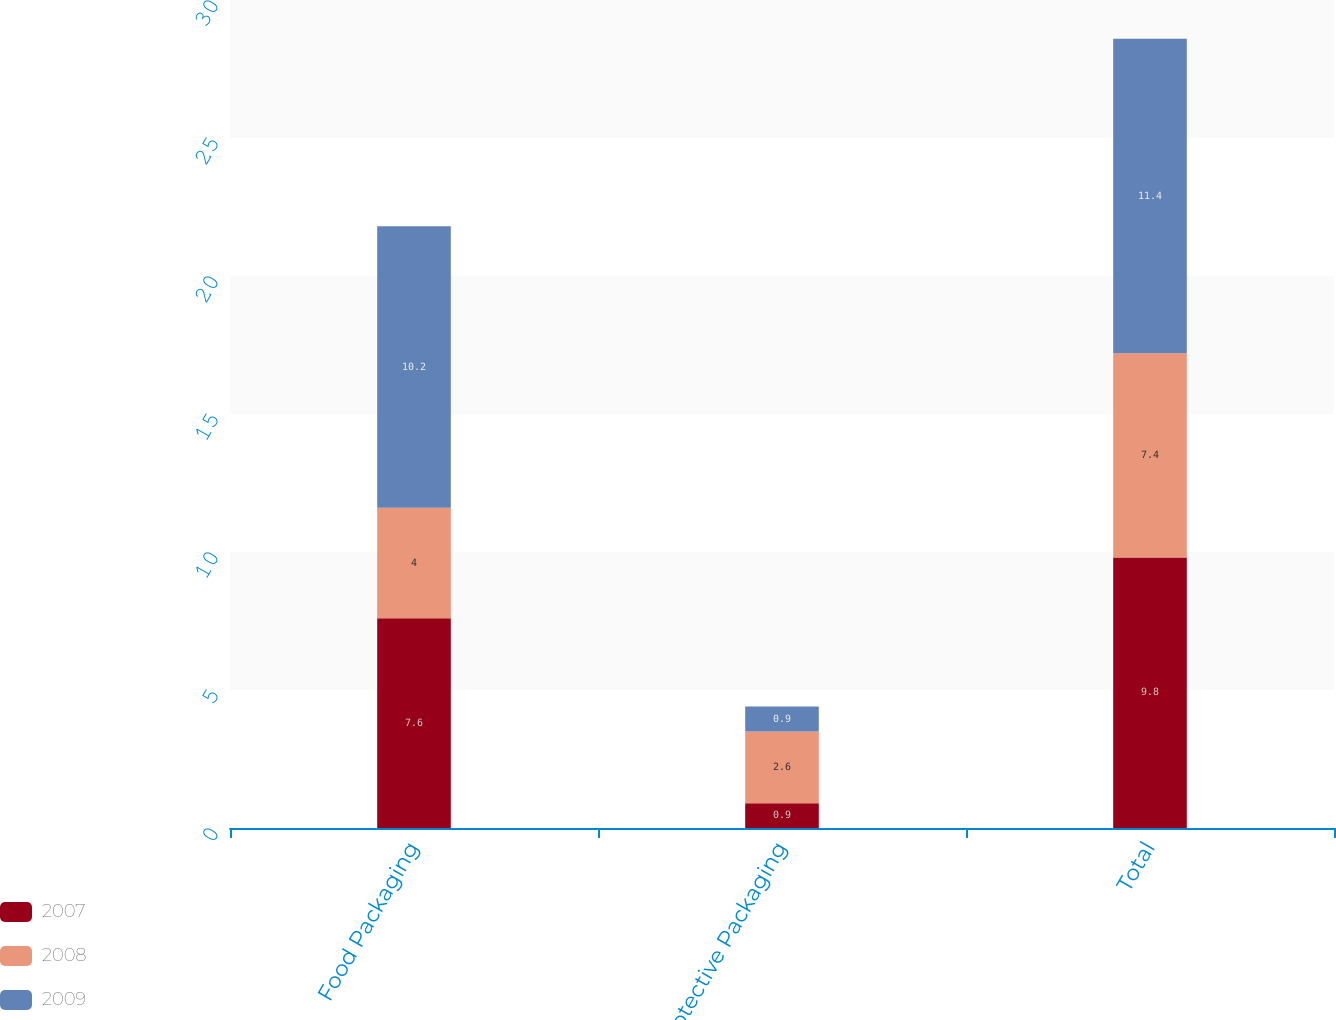Convert chart. <chart><loc_0><loc_0><loc_500><loc_500><stacked_bar_chart><ecel><fcel>Food Packaging<fcel>Protective Packaging<fcel>Total<nl><fcel>2007<fcel>7.6<fcel>0.9<fcel>9.8<nl><fcel>2008<fcel>4<fcel>2.6<fcel>7.4<nl><fcel>2009<fcel>10.2<fcel>0.9<fcel>11.4<nl></chart> 